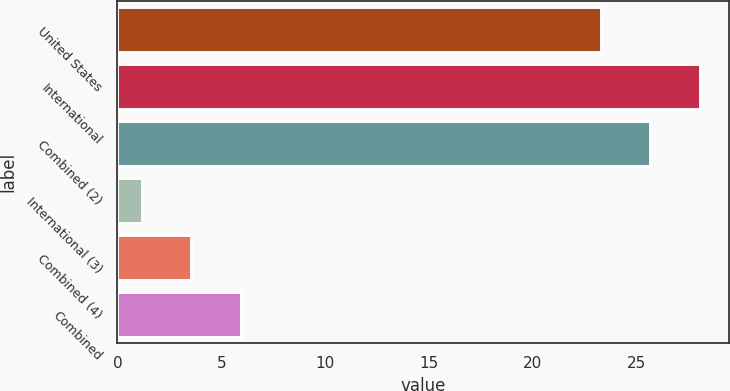<chart> <loc_0><loc_0><loc_500><loc_500><bar_chart><fcel>United States<fcel>International<fcel>Combined (2)<fcel>International (3)<fcel>Combined (4)<fcel>Combined<nl><fcel>23.29<fcel>28.05<fcel>25.67<fcel>1.18<fcel>3.56<fcel>5.94<nl></chart> 